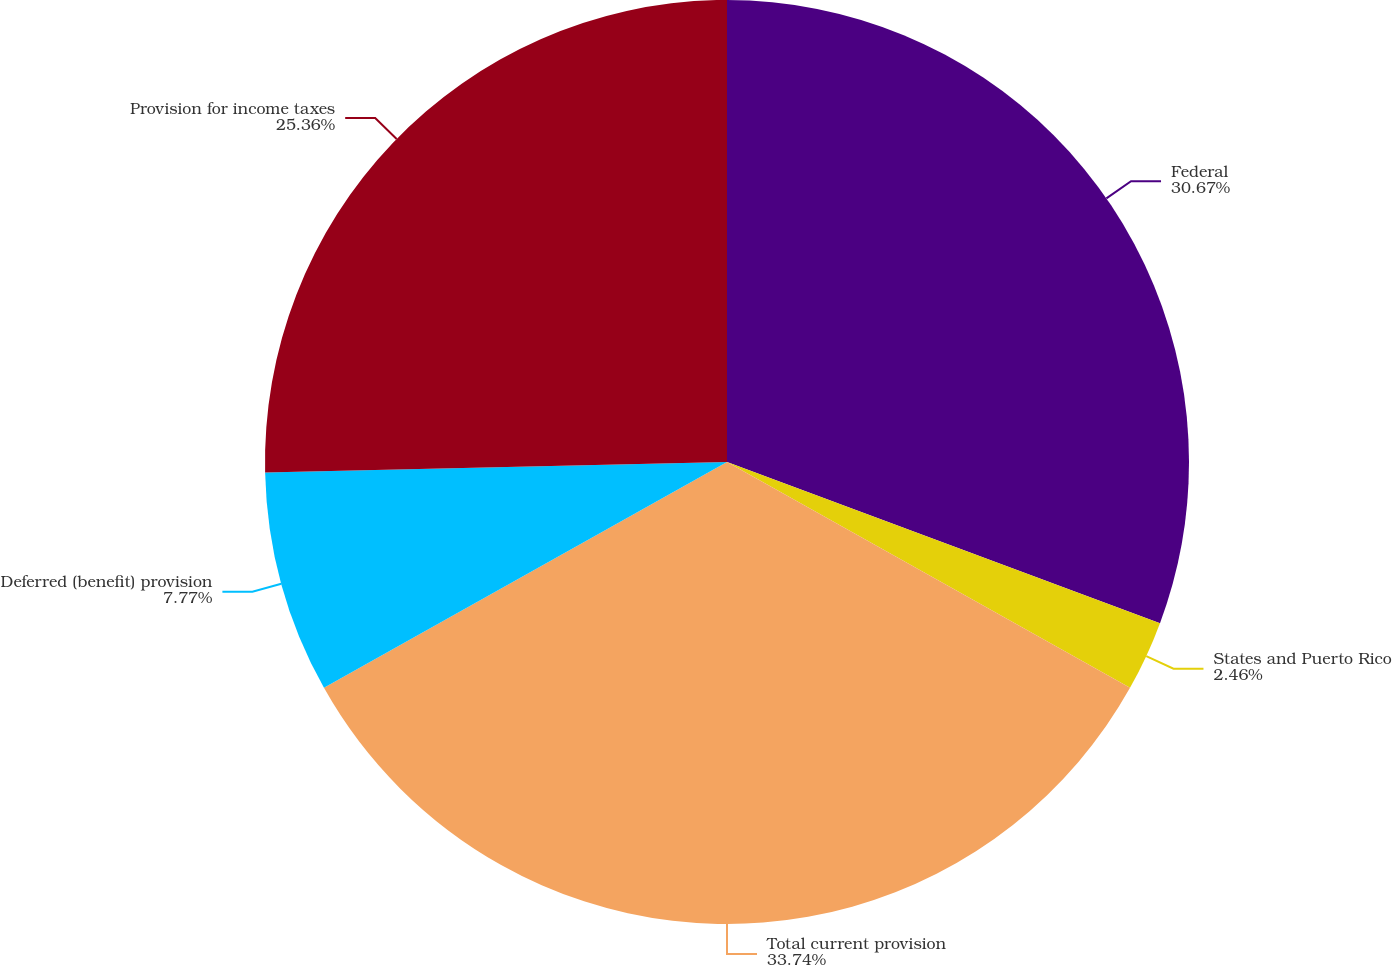Convert chart to OTSL. <chart><loc_0><loc_0><loc_500><loc_500><pie_chart><fcel>Federal<fcel>States and Puerto Rico<fcel>Total current provision<fcel>Deferred (benefit) provision<fcel>Provision for income taxes<nl><fcel>30.67%<fcel>2.46%<fcel>33.74%<fcel>7.77%<fcel>25.36%<nl></chart> 